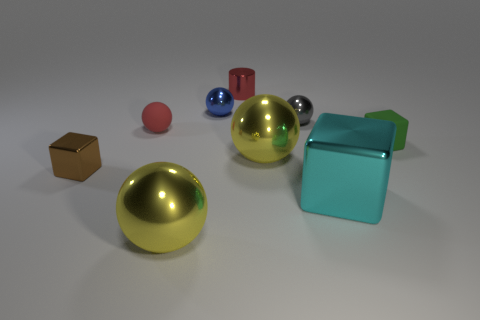How many objects are in front of the red object that is to the left of the yellow sphere on the left side of the tiny metallic cylinder?
Ensure brevity in your answer.  5. Is there anything else of the same color as the shiny cylinder?
Your response must be concise. Yes. Do the small rubber thing right of the cyan metallic object and the large shiny sphere that is in front of the cyan metal thing have the same color?
Provide a succinct answer. No. Is the number of small gray balls in front of the small brown shiny cube greater than the number of metal cubes in front of the green cube?
Your response must be concise. No. What is the big cyan object made of?
Your answer should be compact. Metal. The small gray metallic object that is right of the tiny object in front of the small cube to the right of the small gray shiny object is what shape?
Provide a succinct answer. Sphere. How many other things are there of the same material as the small gray sphere?
Ensure brevity in your answer.  6. Are the yellow thing to the right of the tiny red metallic object and the small block to the right of the tiny blue thing made of the same material?
Your response must be concise. No. What number of things are both to the left of the cyan metal object and behind the large cyan metallic block?
Provide a short and direct response. 6. Is there another small metallic object that has the same shape as the small red metal object?
Keep it short and to the point. No. 